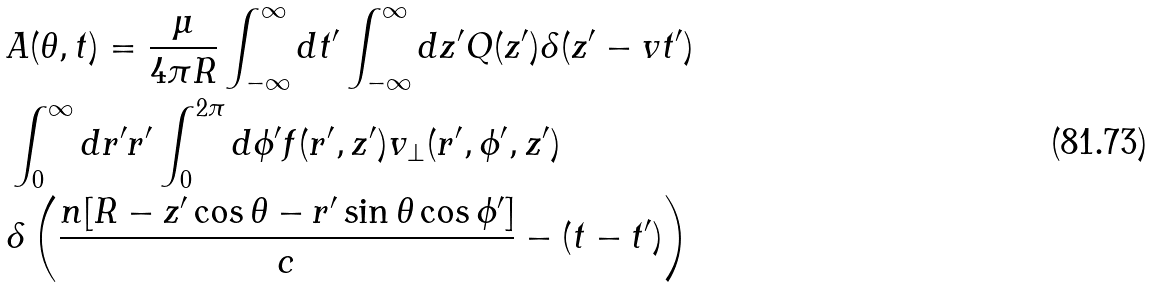<formula> <loc_0><loc_0><loc_500><loc_500>& A ( \theta , t ) = \frac { \mu } { 4 \pi R } \int ^ { \infty } _ { - \infty } d t ^ { \prime } \int ^ { \infty } _ { - \infty } d z ^ { \prime } Q ( z ^ { \prime } ) \delta ( z ^ { \prime } - v t ^ { \prime } ) \\ & \int ^ { \infty } _ { 0 } d r ^ { \prime } r ^ { \prime } \int ^ { 2 \pi } _ { 0 } d \phi ^ { \prime } f ( r ^ { \prime } , z ^ { \prime } ) { v } _ { \perp } ( r ^ { \prime } , \phi ^ { \prime } , z ^ { \prime } ) \\ & \delta \left ( \frac { n [ R - z ^ { \prime } \cos \theta - r ^ { \prime } \sin \theta \cos \phi ^ { \prime } ] } { c } - ( t - t ^ { \prime } ) \right )</formula> 